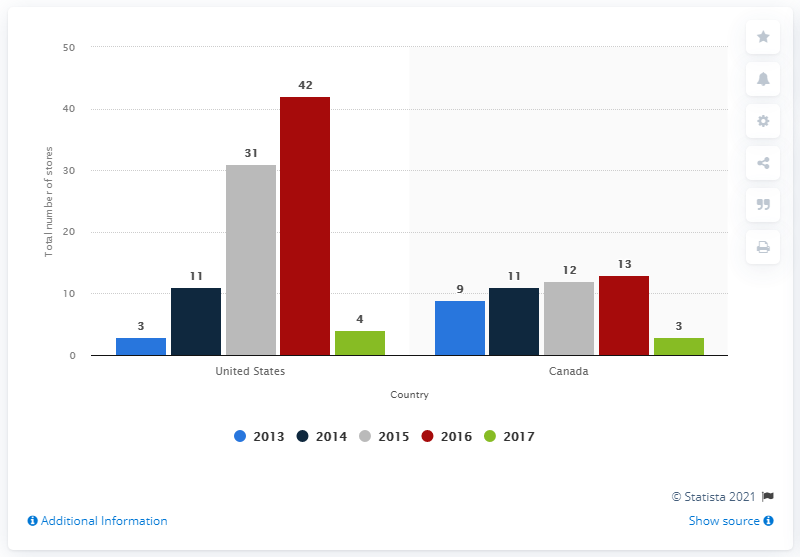Give some essential details in this illustration. In 2016, the color red was used to indicate a specific meaning. In 2017, the total number of stores was 7. 